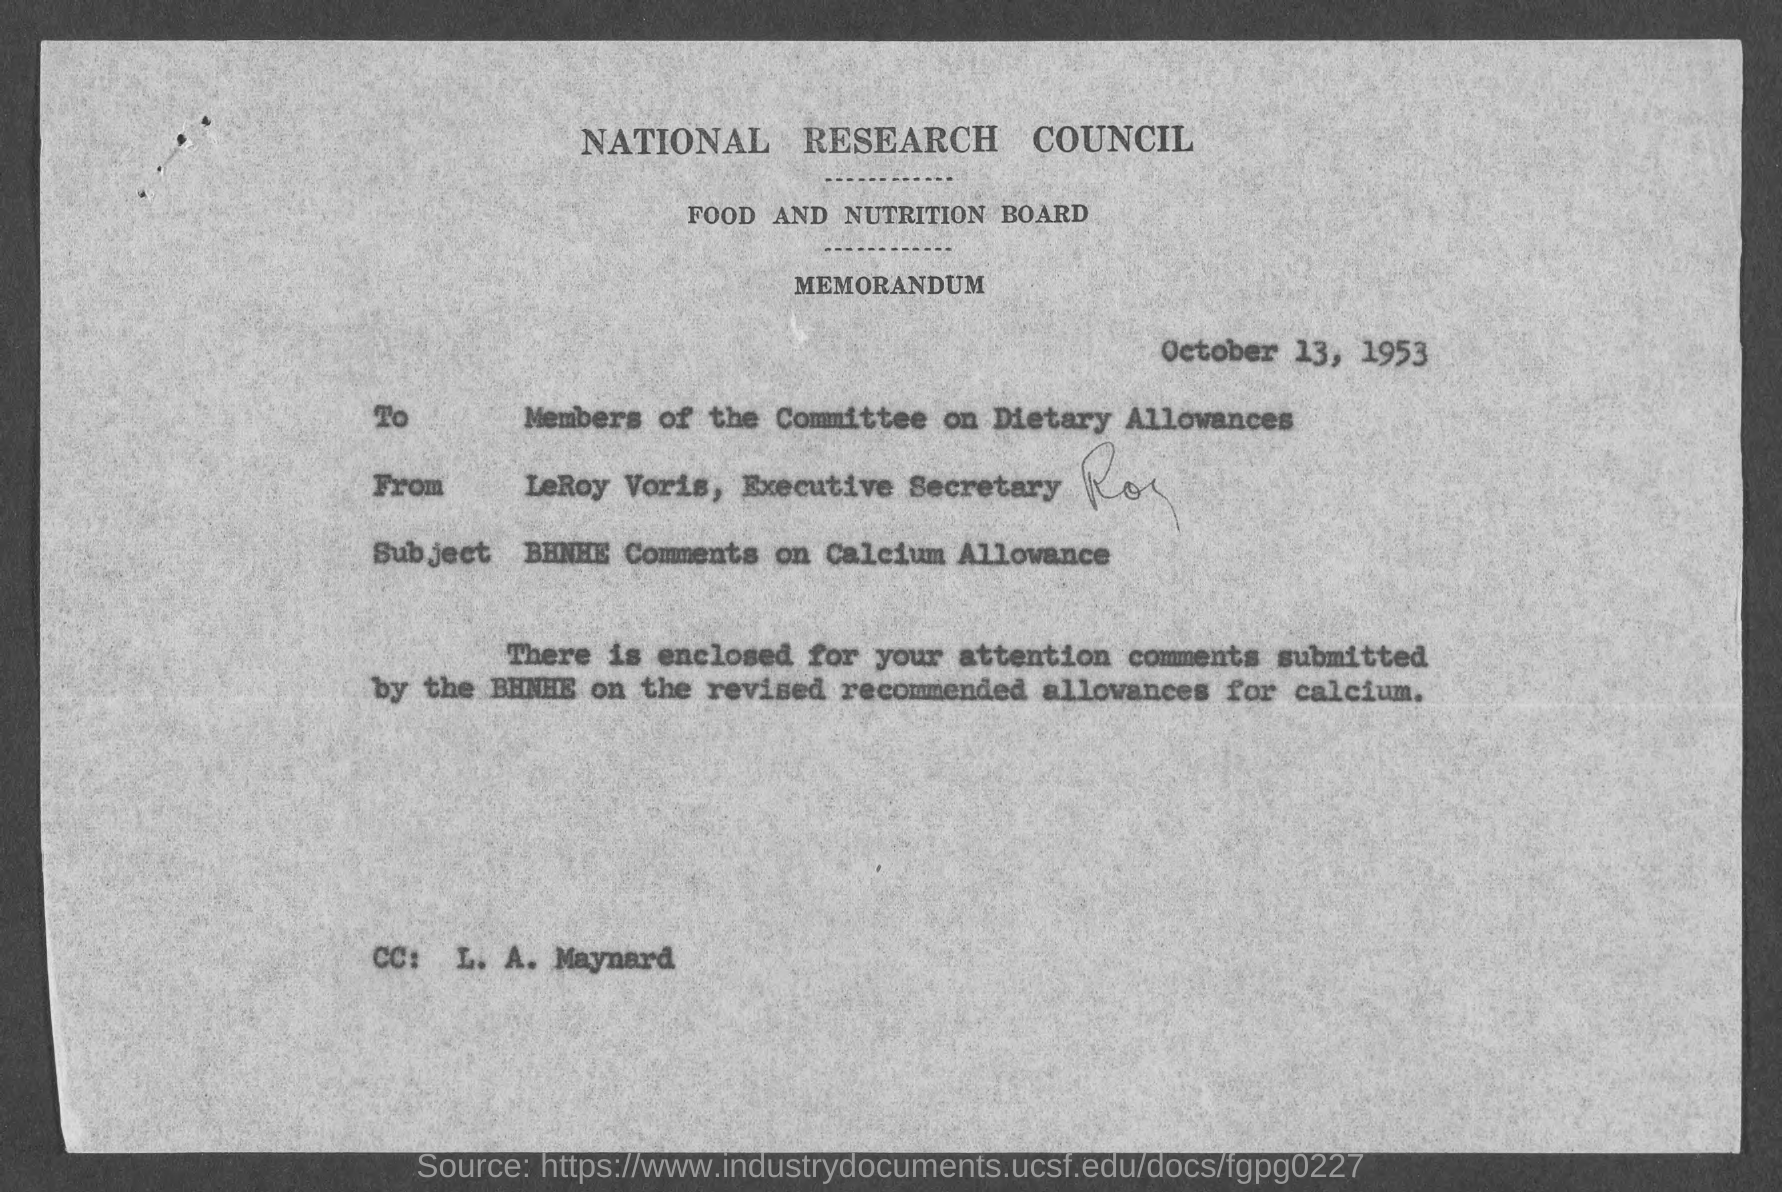Draw attention to some important aspects in this diagram. The Food and Nutrition Board is mentioned. The document is dated October 13, 1953. The CC belongs to L. A. Maynard. The National Research Council is mentioned. The memorandum was sent by LeRoy Voris, the Executive Secretary. 